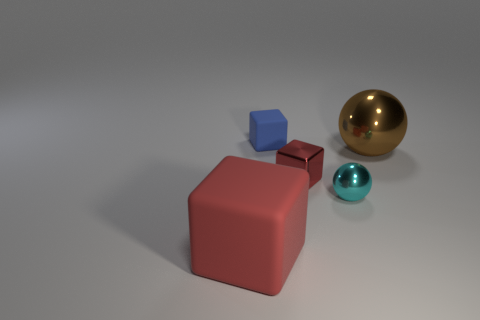Add 2 green rubber things. How many objects exist? 7 Subtract all cubes. How many objects are left? 2 Add 3 small cyan metal objects. How many small cyan metal objects are left? 4 Add 2 rubber things. How many rubber things exist? 4 Subtract 0 gray spheres. How many objects are left? 5 Subtract all brown metallic cubes. Subtract all big brown metal spheres. How many objects are left? 4 